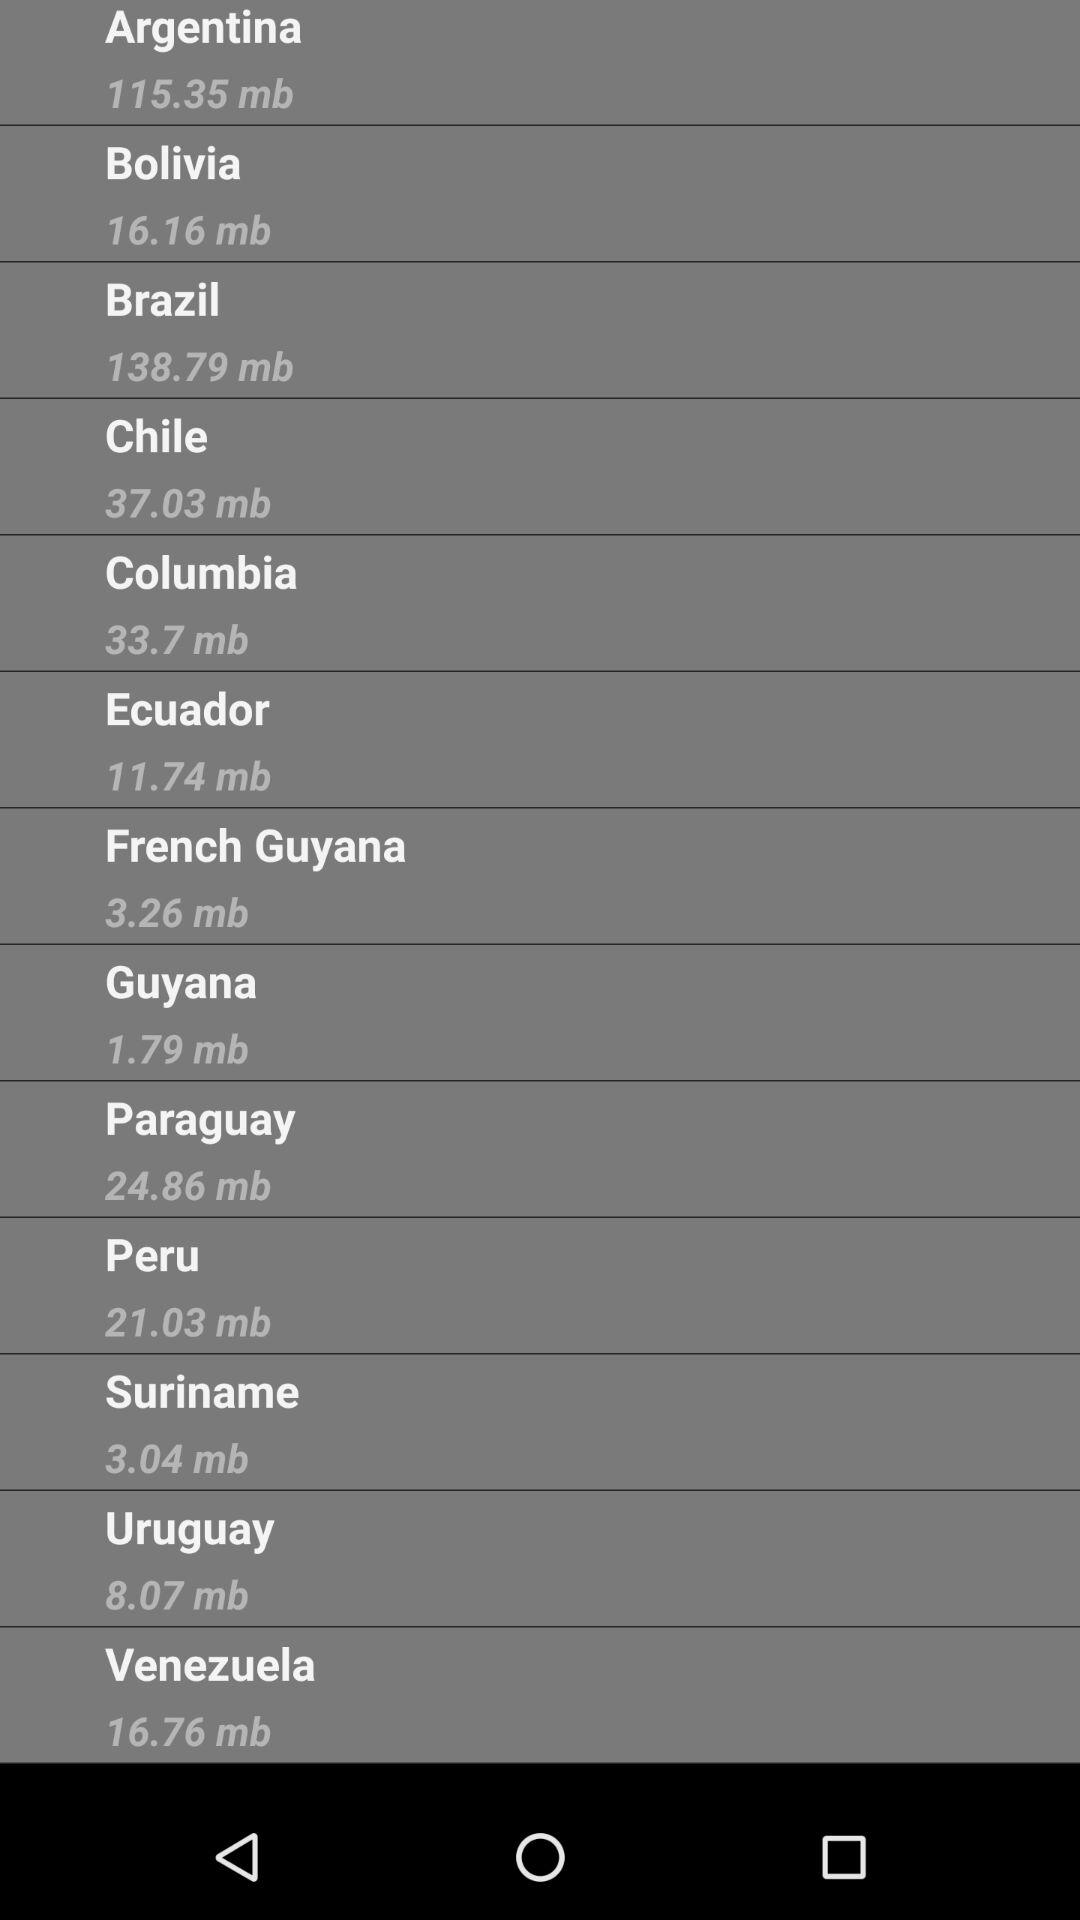What is the size of the file "Columbia" in mb? The size of the file is 33.7 mb. 